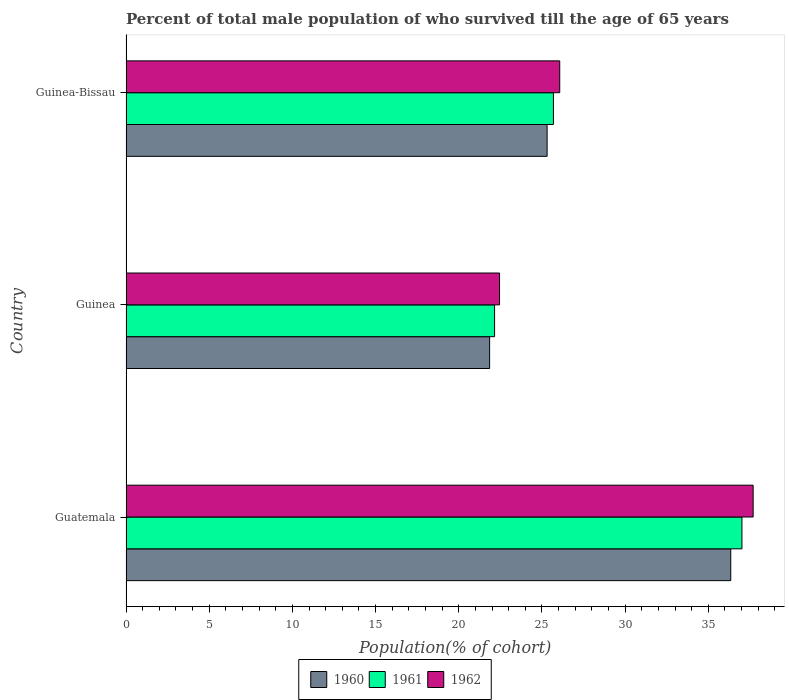How many different coloured bars are there?
Give a very brief answer. 3. How many groups of bars are there?
Give a very brief answer. 3. Are the number of bars per tick equal to the number of legend labels?
Give a very brief answer. Yes. Are the number of bars on each tick of the Y-axis equal?
Your response must be concise. Yes. What is the label of the 1st group of bars from the top?
Provide a short and direct response. Guinea-Bissau. What is the percentage of total male population who survived till the age of 65 years in 1960 in Guinea-Bissau?
Offer a terse response. 25.31. Across all countries, what is the maximum percentage of total male population who survived till the age of 65 years in 1960?
Offer a terse response. 36.35. Across all countries, what is the minimum percentage of total male population who survived till the age of 65 years in 1962?
Offer a terse response. 22.45. In which country was the percentage of total male population who survived till the age of 65 years in 1960 maximum?
Give a very brief answer. Guatemala. In which country was the percentage of total male population who survived till the age of 65 years in 1961 minimum?
Provide a short and direct response. Guinea. What is the total percentage of total male population who survived till the age of 65 years in 1960 in the graph?
Offer a very short reply. 83.51. What is the difference between the percentage of total male population who survived till the age of 65 years in 1961 in Guinea and that in Guinea-Bissau?
Give a very brief answer. -3.54. What is the difference between the percentage of total male population who survived till the age of 65 years in 1961 in Guatemala and the percentage of total male population who survived till the age of 65 years in 1960 in Guinea-Bissau?
Give a very brief answer. 11.71. What is the average percentage of total male population who survived till the age of 65 years in 1962 per country?
Offer a terse response. 28.74. What is the difference between the percentage of total male population who survived till the age of 65 years in 1960 and percentage of total male population who survived till the age of 65 years in 1961 in Guatemala?
Make the answer very short. -0.67. In how many countries, is the percentage of total male population who survived till the age of 65 years in 1960 greater than 22 %?
Ensure brevity in your answer.  2. What is the ratio of the percentage of total male population who survived till the age of 65 years in 1960 in Guinea to that in Guinea-Bissau?
Make the answer very short. 0.86. What is the difference between the highest and the second highest percentage of total male population who survived till the age of 65 years in 1961?
Offer a very short reply. 11.33. What is the difference between the highest and the lowest percentage of total male population who survived till the age of 65 years in 1961?
Your answer should be compact. 14.87. In how many countries, is the percentage of total male population who survived till the age of 65 years in 1960 greater than the average percentage of total male population who survived till the age of 65 years in 1960 taken over all countries?
Ensure brevity in your answer.  1. What does the 3rd bar from the bottom in Guinea represents?
Your answer should be very brief. 1962. Is it the case that in every country, the sum of the percentage of total male population who survived till the age of 65 years in 1962 and percentage of total male population who survived till the age of 65 years in 1961 is greater than the percentage of total male population who survived till the age of 65 years in 1960?
Your answer should be compact. Yes. Are all the bars in the graph horizontal?
Offer a very short reply. Yes. Does the graph contain grids?
Make the answer very short. No. Where does the legend appear in the graph?
Give a very brief answer. Bottom center. How many legend labels are there?
Offer a very short reply. 3. What is the title of the graph?
Offer a terse response. Percent of total male population of who survived till the age of 65 years. What is the label or title of the X-axis?
Offer a terse response. Population(% of cohort). What is the Population(% of cohort) in 1960 in Guatemala?
Provide a succinct answer. 36.35. What is the Population(% of cohort) of 1961 in Guatemala?
Provide a succinct answer. 37.02. What is the Population(% of cohort) in 1962 in Guatemala?
Give a very brief answer. 37.69. What is the Population(% of cohort) of 1960 in Guinea?
Offer a terse response. 21.85. What is the Population(% of cohort) in 1961 in Guinea?
Your answer should be very brief. 22.15. What is the Population(% of cohort) in 1962 in Guinea?
Give a very brief answer. 22.45. What is the Population(% of cohort) in 1960 in Guinea-Bissau?
Provide a succinct answer. 25.31. What is the Population(% of cohort) in 1961 in Guinea-Bissau?
Provide a succinct answer. 25.69. What is the Population(% of cohort) of 1962 in Guinea-Bissau?
Provide a short and direct response. 26.07. Across all countries, what is the maximum Population(% of cohort) of 1960?
Offer a terse response. 36.35. Across all countries, what is the maximum Population(% of cohort) in 1961?
Your answer should be compact. 37.02. Across all countries, what is the maximum Population(% of cohort) of 1962?
Provide a short and direct response. 37.69. Across all countries, what is the minimum Population(% of cohort) in 1960?
Offer a terse response. 21.85. Across all countries, what is the minimum Population(% of cohort) of 1961?
Ensure brevity in your answer.  22.15. Across all countries, what is the minimum Population(% of cohort) of 1962?
Your answer should be compact. 22.45. What is the total Population(% of cohort) in 1960 in the graph?
Your response must be concise. 83.51. What is the total Population(% of cohort) in 1961 in the graph?
Keep it short and to the point. 84.86. What is the total Population(% of cohort) of 1962 in the graph?
Give a very brief answer. 86.21. What is the difference between the Population(% of cohort) in 1960 in Guatemala and that in Guinea?
Offer a terse response. 14.49. What is the difference between the Population(% of cohort) of 1961 in Guatemala and that in Guinea?
Your answer should be very brief. 14.87. What is the difference between the Population(% of cohort) in 1962 in Guatemala and that in Guinea?
Provide a succinct answer. 15.24. What is the difference between the Population(% of cohort) of 1960 in Guatemala and that in Guinea-Bissau?
Your response must be concise. 11.04. What is the difference between the Population(% of cohort) of 1961 in Guatemala and that in Guinea-Bissau?
Provide a short and direct response. 11.33. What is the difference between the Population(% of cohort) of 1962 in Guatemala and that in Guinea-Bissau?
Your answer should be compact. 11.62. What is the difference between the Population(% of cohort) of 1960 in Guinea and that in Guinea-Bissau?
Provide a short and direct response. -3.46. What is the difference between the Population(% of cohort) of 1961 in Guinea and that in Guinea-Bissau?
Keep it short and to the point. -3.54. What is the difference between the Population(% of cohort) of 1962 in Guinea and that in Guinea-Bissau?
Keep it short and to the point. -3.62. What is the difference between the Population(% of cohort) of 1960 in Guatemala and the Population(% of cohort) of 1961 in Guinea?
Your response must be concise. 14.19. What is the difference between the Population(% of cohort) in 1960 in Guatemala and the Population(% of cohort) in 1962 in Guinea?
Your answer should be compact. 13.9. What is the difference between the Population(% of cohort) in 1961 in Guatemala and the Population(% of cohort) in 1962 in Guinea?
Your answer should be very brief. 14.57. What is the difference between the Population(% of cohort) of 1960 in Guatemala and the Population(% of cohort) of 1961 in Guinea-Bissau?
Provide a short and direct response. 10.66. What is the difference between the Population(% of cohort) in 1960 in Guatemala and the Population(% of cohort) in 1962 in Guinea-Bissau?
Your response must be concise. 10.28. What is the difference between the Population(% of cohort) in 1961 in Guatemala and the Population(% of cohort) in 1962 in Guinea-Bissau?
Your answer should be very brief. 10.95. What is the difference between the Population(% of cohort) of 1960 in Guinea and the Population(% of cohort) of 1961 in Guinea-Bissau?
Offer a very short reply. -3.83. What is the difference between the Population(% of cohort) in 1960 in Guinea and the Population(% of cohort) in 1962 in Guinea-Bissau?
Give a very brief answer. -4.21. What is the difference between the Population(% of cohort) of 1961 in Guinea and the Population(% of cohort) of 1962 in Guinea-Bissau?
Your response must be concise. -3.92. What is the average Population(% of cohort) of 1960 per country?
Give a very brief answer. 27.84. What is the average Population(% of cohort) in 1961 per country?
Ensure brevity in your answer.  28.29. What is the average Population(% of cohort) of 1962 per country?
Give a very brief answer. 28.74. What is the difference between the Population(% of cohort) in 1960 and Population(% of cohort) in 1961 in Guatemala?
Make the answer very short. -0.67. What is the difference between the Population(% of cohort) in 1960 and Population(% of cohort) in 1962 in Guatemala?
Your response must be concise. -1.35. What is the difference between the Population(% of cohort) in 1961 and Population(% of cohort) in 1962 in Guatemala?
Offer a terse response. -0.67. What is the difference between the Population(% of cohort) in 1960 and Population(% of cohort) in 1961 in Guinea?
Provide a short and direct response. -0.3. What is the difference between the Population(% of cohort) of 1960 and Population(% of cohort) of 1962 in Guinea?
Offer a very short reply. -0.6. What is the difference between the Population(% of cohort) in 1961 and Population(% of cohort) in 1962 in Guinea?
Your response must be concise. -0.3. What is the difference between the Population(% of cohort) of 1960 and Population(% of cohort) of 1961 in Guinea-Bissau?
Your answer should be compact. -0.38. What is the difference between the Population(% of cohort) in 1960 and Population(% of cohort) in 1962 in Guinea-Bissau?
Ensure brevity in your answer.  -0.76. What is the difference between the Population(% of cohort) of 1961 and Population(% of cohort) of 1962 in Guinea-Bissau?
Ensure brevity in your answer.  -0.38. What is the ratio of the Population(% of cohort) of 1960 in Guatemala to that in Guinea?
Provide a short and direct response. 1.66. What is the ratio of the Population(% of cohort) in 1961 in Guatemala to that in Guinea?
Your answer should be very brief. 1.67. What is the ratio of the Population(% of cohort) of 1962 in Guatemala to that in Guinea?
Offer a terse response. 1.68. What is the ratio of the Population(% of cohort) of 1960 in Guatemala to that in Guinea-Bissau?
Provide a short and direct response. 1.44. What is the ratio of the Population(% of cohort) in 1961 in Guatemala to that in Guinea-Bissau?
Your answer should be compact. 1.44. What is the ratio of the Population(% of cohort) of 1962 in Guatemala to that in Guinea-Bissau?
Keep it short and to the point. 1.45. What is the ratio of the Population(% of cohort) of 1960 in Guinea to that in Guinea-Bissau?
Keep it short and to the point. 0.86. What is the ratio of the Population(% of cohort) in 1961 in Guinea to that in Guinea-Bissau?
Your answer should be very brief. 0.86. What is the ratio of the Population(% of cohort) of 1962 in Guinea to that in Guinea-Bissau?
Ensure brevity in your answer.  0.86. What is the difference between the highest and the second highest Population(% of cohort) of 1960?
Offer a very short reply. 11.04. What is the difference between the highest and the second highest Population(% of cohort) in 1961?
Your answer should be very brief. 11.33. What is the difference between the highest and the second highest Population(% of cohort) of 1962?
Ensure brevity in your answer.  11.62. What is the difference between the highest and the lowest Population(% of cohort) of 1960?
Your response must be concise. 14.49. What is the difference between the highest and the lowest Population(% of cohort) in 1961?
Ensure brevity in your answer.  14.87. What is the difference between the highest and the lowest Population(% of cohort) of 1962?
Give a very brief answer. 15.24. 